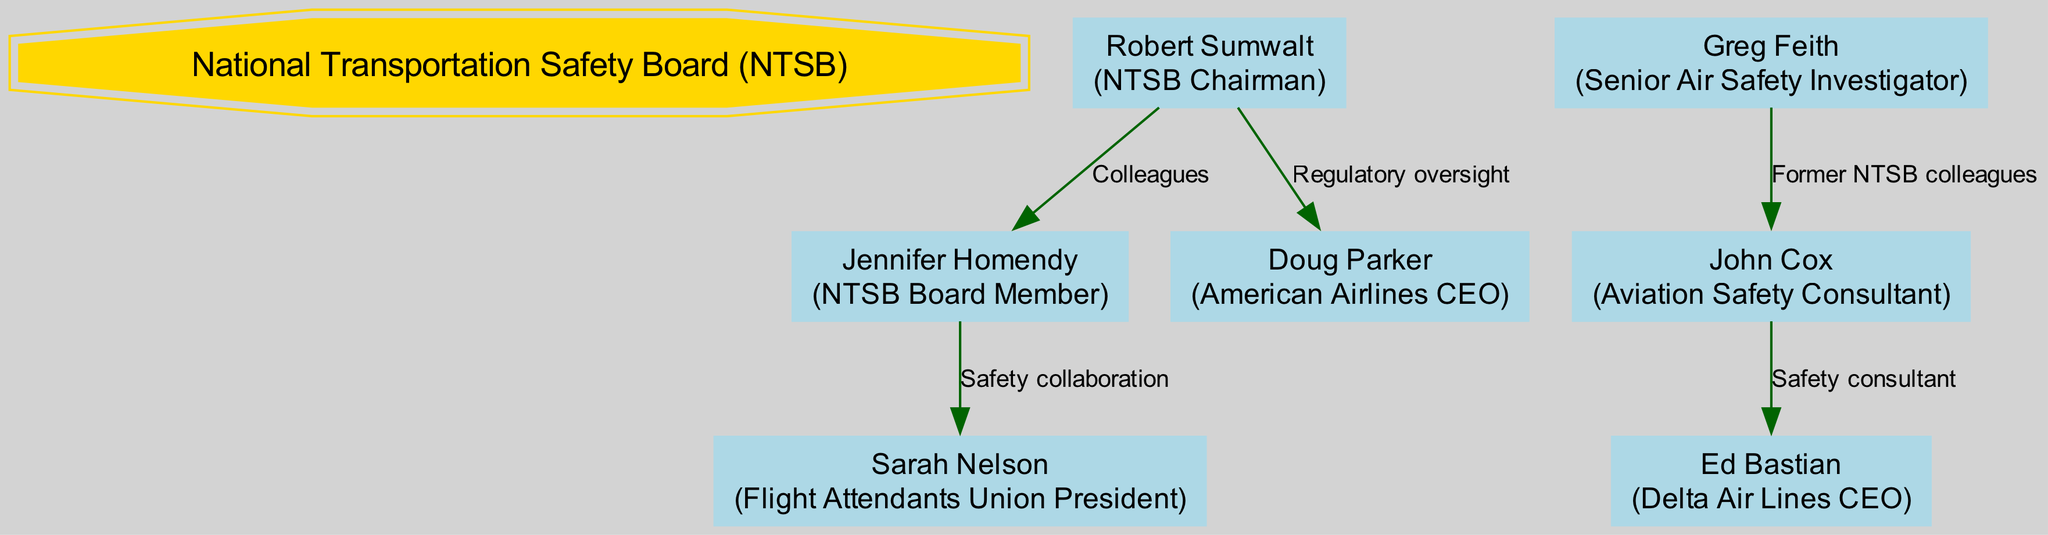What is the total number of nodes in the diagram? By counting each individual person or entity that appears in the diagram, we find there are seven distinct nodes: the NTSB and six individuals or roles.
Answer: 7 Who is the NTSB Chairman? The label for the NTSB Chairman node in the diagram clearly states "Robert Sumwalt."
Answer: Robert Sumwalt What is the relationship between Robert Sumwalt and Doug Parker? The diagram explicitly shows that Robert Sumwalt has a "Regulatory oversight" relationship with Doug Parker.
Answer: Regulatory oversight Which role does Sarah Nelson hold? The diagram includes a box that indicates Sarah Nelson's role as the "Flight Attendants Union President."
Answer: Flight Attendants Union President How many relationships are shown in the diagram? Counting each relationship line depicted in the diagram, we see there are five distinct relationships connecting the various nodes.
Answer: 5 What type of relationship exists between Greg Feith and John Cox? The diagram specifies the connection between Greg Feith and John Cox as "Former NTSB colleagues."
Answer: Former NTSB colleagues Which node is directly connected to Jennifer Homendy? The diagram shows that Jennifer Homendy is directly connected to both Robert Sumwalt and Sarah Nelson, based on the relationships provided.
Answer: Robert Sumwalt, Sarah Nelson Who provides safety consulting to Ed Bastian? The diagram indicates that John Cox has a "Safety consultant" relationship with Ed Bastian, implying John Cox provides safety consulting.
Answer: John Cox What is the role of Doug Parker in the diagram? The labeled role next to Doug Parker in the diagram identifies him as the "American Airlines CEO."
Answer: American Airlines CEO 